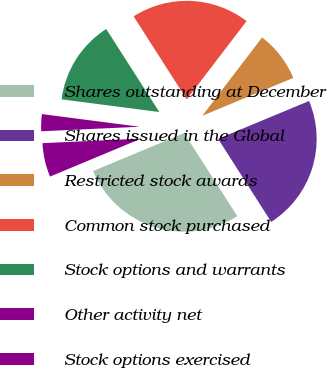Convert chart to OTSL. <chart><loc_0><loc_0><loc_500><loc_500><pie_chart><fcel>Shares outstanding at December<fcel>Shares issued in the Global<fcel>Restricted stock awards<fcel>Common stock purchased<fcel>Stock options and warrants<fcel>Other activity net<fcel>Stock options exercised<nl><fcel>27.77%<fcel>22.22%<fcel>8.34%<fcel>19.44%<fcel>13.89%<fcel>2.78%<fcel>5.56%<nl></chart> 